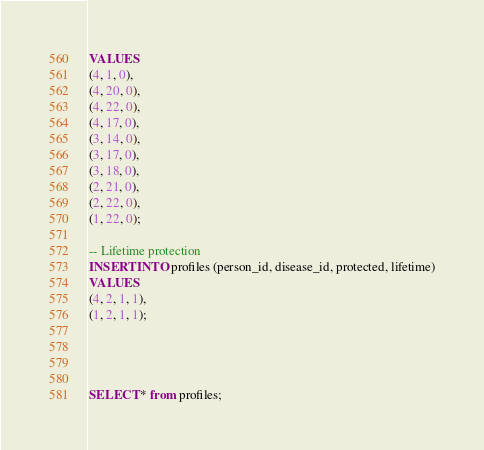<code> <loc_0><loc_0><loc_500><loc_500><_SQL_>VALUES 
(4, 1, 0),
(4, 20, 0),
(4, 22, 0),
(4, 17, 0),
(3, 14, 0),
(3, 17, 0),
(3, 18, 0),
(2, 21, 0),
(2, 22, 0),
(1, 22, 0);

-- Lifetime protection
INSERT INTO profiles (person_id, disease_id, protected, lifetime)
VALUES 
(4, 2, 1, 1),
(1, 2, 1, 1);




SELECT * from profiles;</code> 